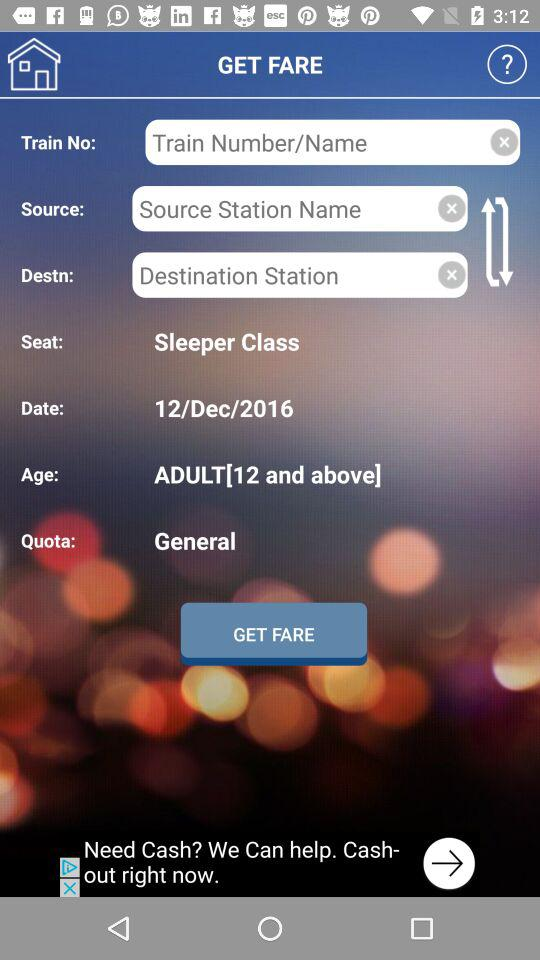What is the type of coach selected? - What type of seat is selected? The selected type of seat is sleeper class. 